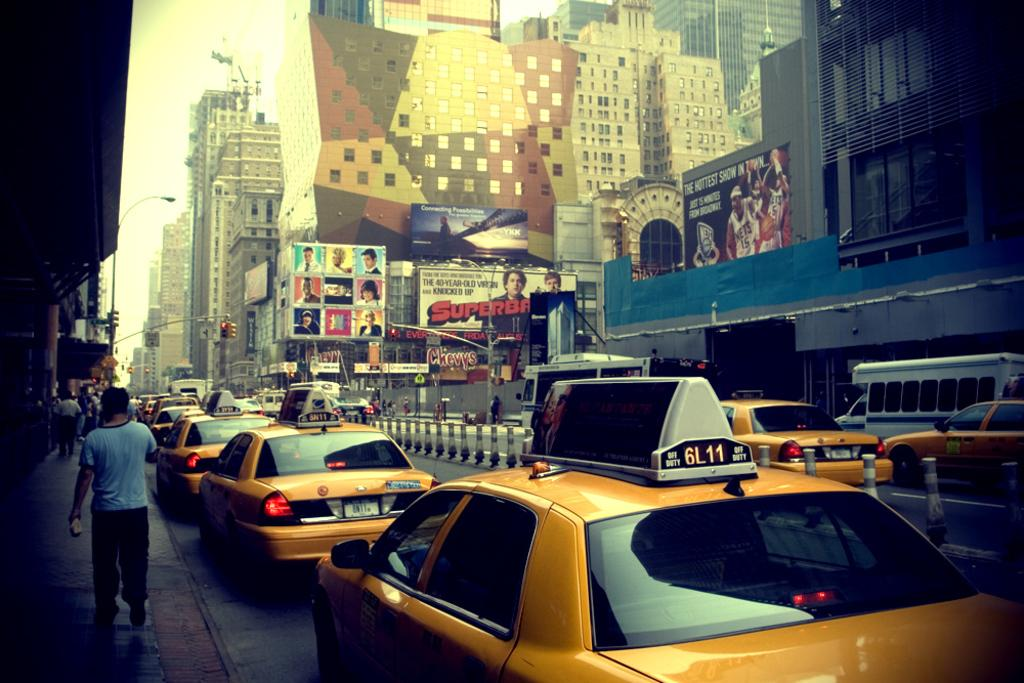Provide a one-sentence caption for the provided image. A Picture looks like a downtown with lines of Yellow cabs and people walking on the sidewalk. 